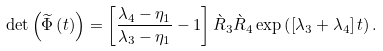Convert formula to latex. <formula><loc_0><loc_0><loc_500><loc_500>\det \left ( \widetilde { \Phi } \left ( t \right ) \right ) & = \left [ \frac { \lambda _ { 4 } - \eta _ { 1 } } { \lambda _ { 3 } - \eta _ { 1 } } - 1 \right ] \grave { R } _ { 3 } \grave { R } _ { 4 } \exp \left ( \left [ \lambda _ { 3 } + \lambda _ { 4 } \right ] t \right ) .</formula> 